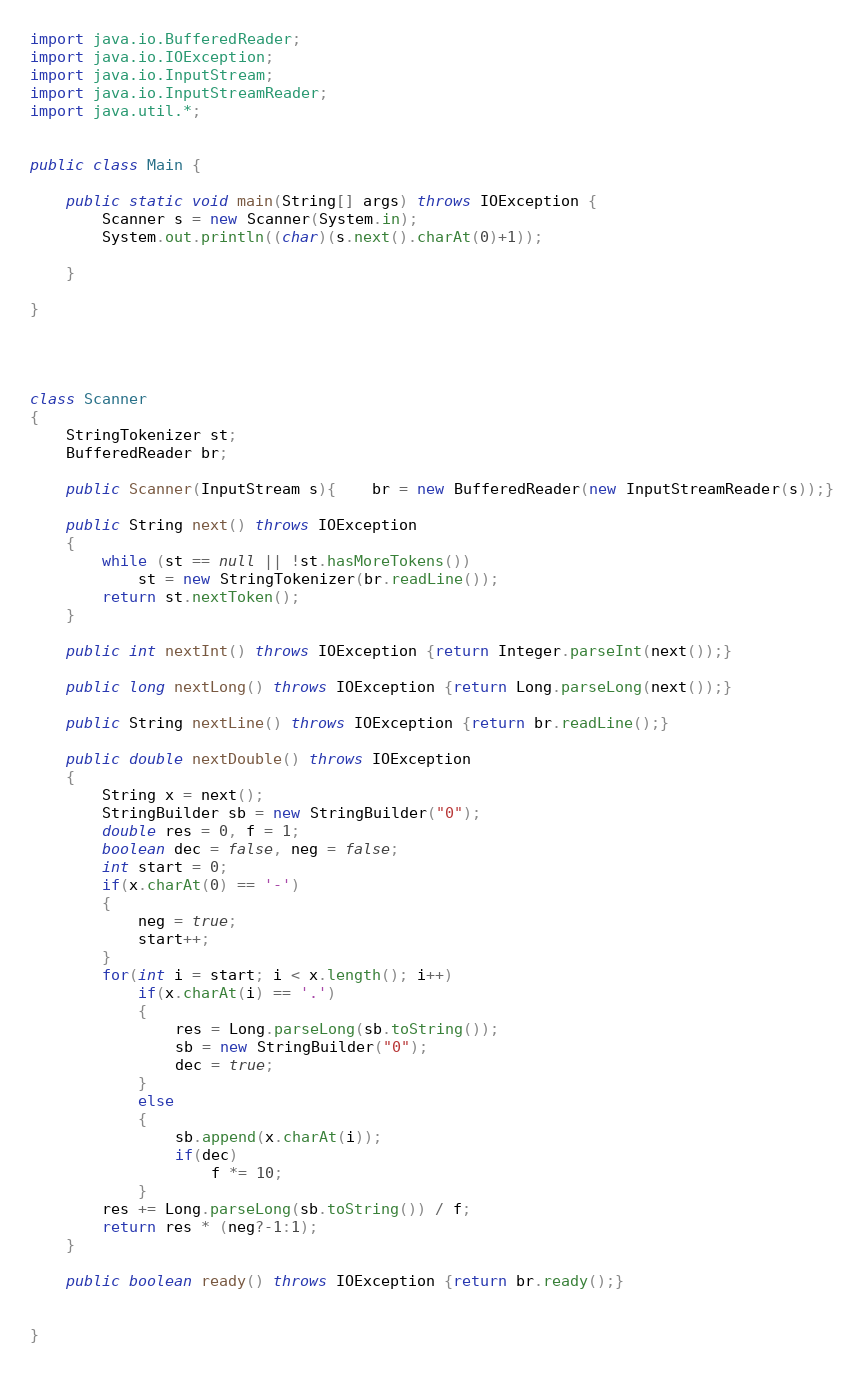Convert code to text. <code><loc_0><loc_0><loc_500><loc_500><_Java_>
import java.io.BufferedReader;
import java.io.IOException;
import java.io.InputStream;
import java.io.InputStreamReader;
import java.util.*;


public class Main {

    public static void main(String[] args) throws IOException {
        Scanner s = new Scanner(System.in);
        System.out.println((char)(s.next().charAt(0)+1));

    }

}




class Scanner
{
    StringTokenizer st;
    BufferedReader br;

    public Scanner(InputStream s){	br = new BufferedReader(new InputStreamReader(s));}

    public String next() throws IOException
    {
        while (st == null || !st.hasMoreTokens())
            st = new StringTokenizer(br.readLine());
        return st.nextToken();
    }

    public int nextInt() throws IOException {return Integer.parseInt(next());}

    public long nextLong() throws IOException {return Long.parseLong(next());}

    public String nextLine() throws IOException {return br.readLine();}

    public double nextDouble() throws IOException
    {
        String x = next();
        StringBuilder sb = new StringBuilder("0");
        double res = 0, f = 1;
        boolean dec = false, neg = false;
        int start = 0;
        if(x.charAt(0) == '-')
        {
            neg = true;
            start++;
        }
        for(int i = start; i < x.length(); i++)
            if(x.charAt(i) == '.')
            {
                res = Long.parseLong(sb.toString());
                sb = new StringBuilder("0");
                dec = true;
            }
            else
            {
                sb.append(x.charAt(i));
                if(dec)
                    f *= 10;
            }
        res += Long.parseLong(sb.toString()) / f;
        return res * (neg?-1:1);
    }

    public boolean ready() throws IOException {return br.ready();}


}</code> 